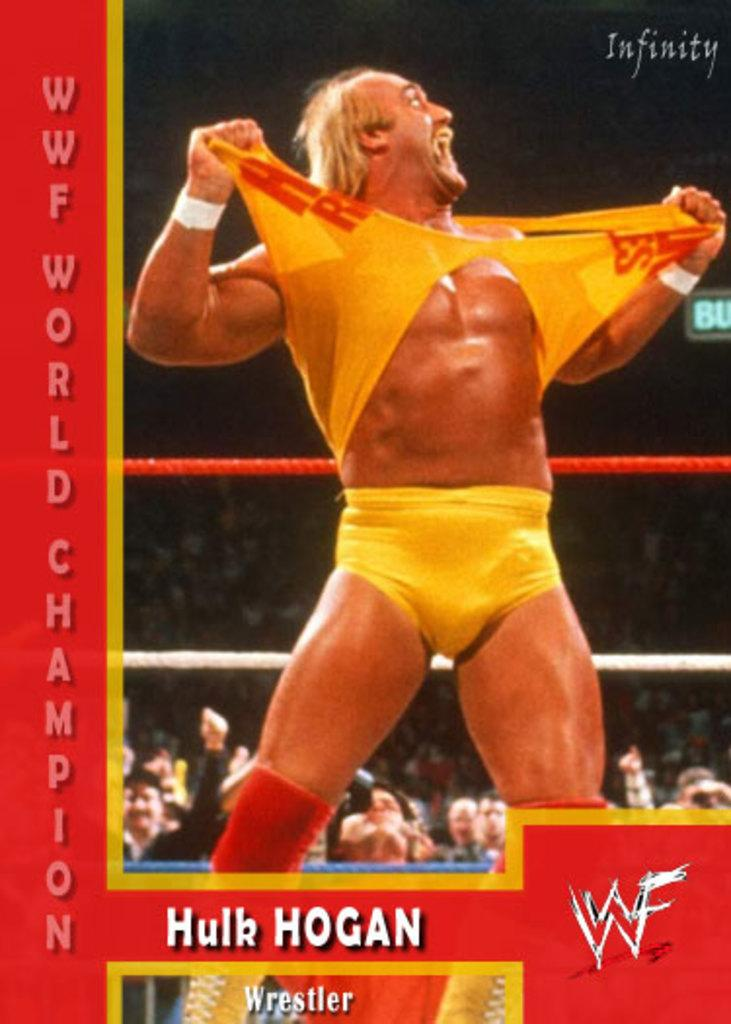<image>
Offer a succinct explanation of the picture presented. Hulk Hogan rips off his yellow shirt, as he tends to do. 